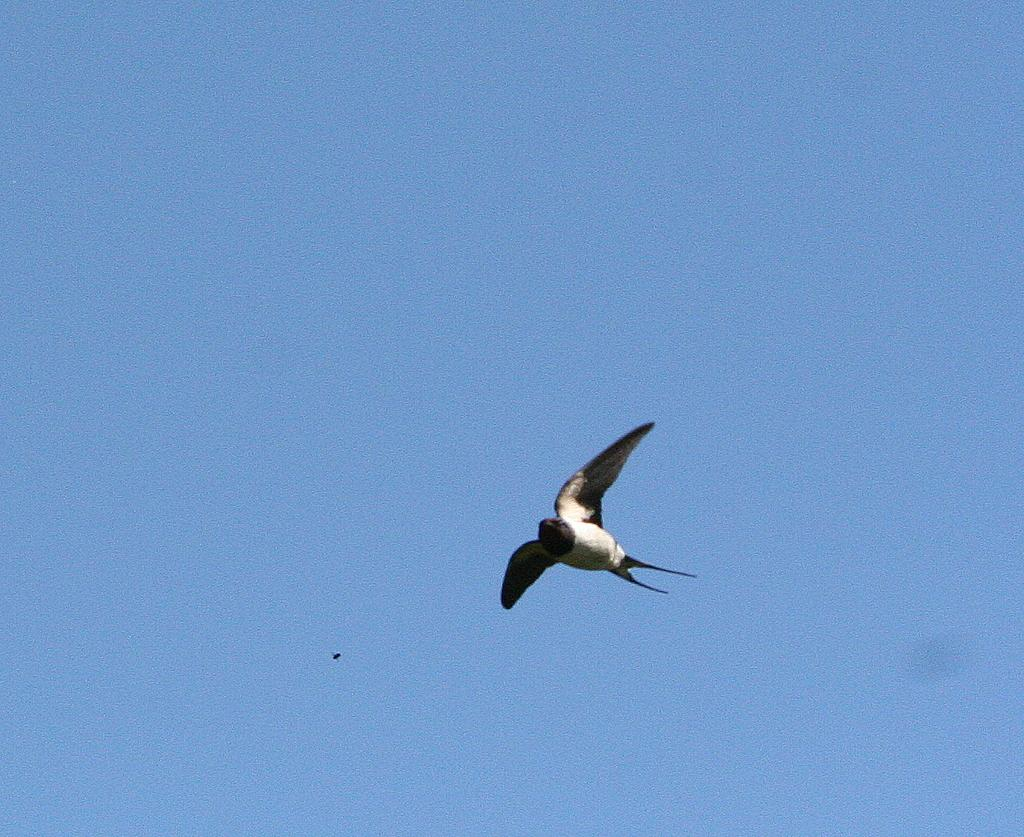What is the main subject of the image? There is a bird in the center of the image. What can be seen in the background of the image? There is sky visible in the background of the image. What route does the bird's owner take to walk the bird in the image? There is no indication of an owner or a route in the image, as it only features a bird and the sky. 